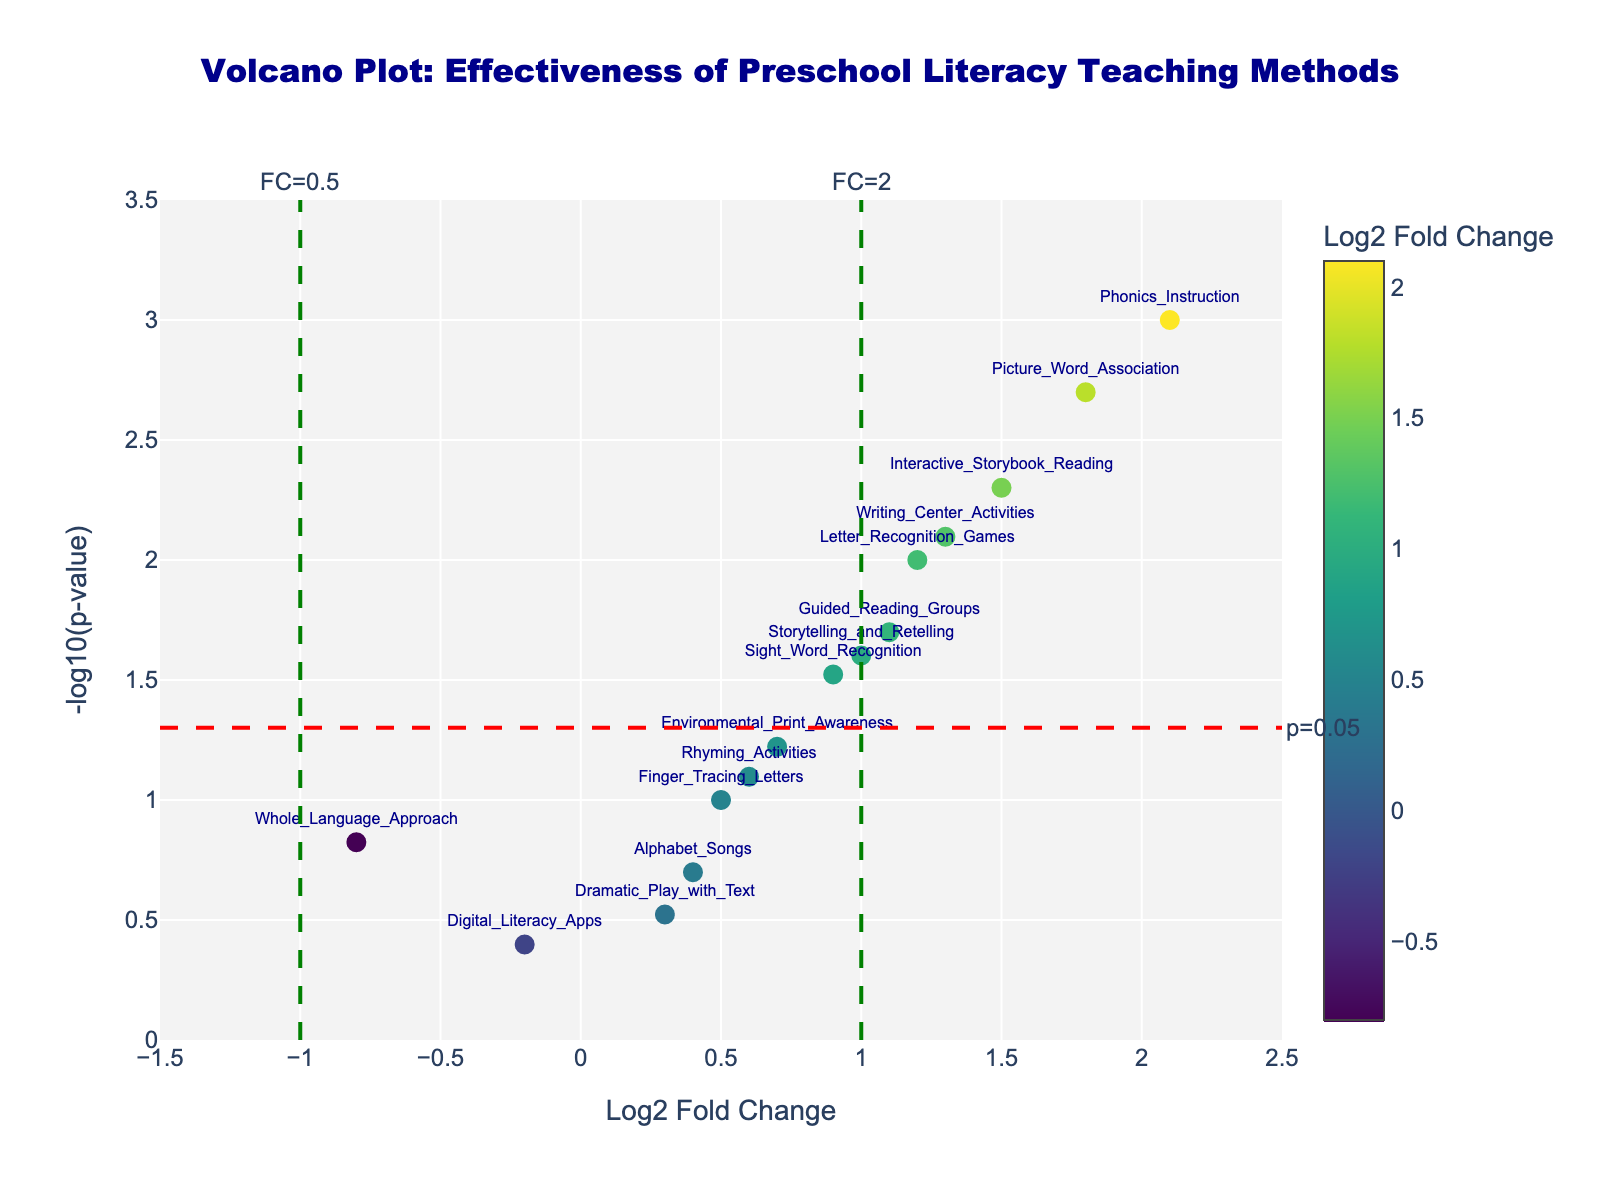How many teaching methods are shown in the volcano plot? Count the number of markers representing teaching methods in the figure. Each marker corresponds to one method.
Answer: 15 Which teaching method has the highest log2 fold change? Identify the marker positioned furthest to the right on the x-axis (log2 fold change) and check the label or hover text.
Answer: Phonics Instruction What is the p-value threshold represented by the horizontal red dashed line? The annotation on the horizontal red dashed line indicates the p-value threshold. The value is typically marked next to the line.
Answer: 0.05 Which teaching methods are considered statistically significant? Look for markers above the horizontal red dashed line (p=0.05) since these values have -log10(p) > -log10(0.05).
Answer: Phonics Instruction, Interactive Storybook Reading, Picture Word Association, Writing Center Activities, Guided Reading Groups, Sight Word Recognition, Storytelling and Retelling, Letter Recognition Games What is the log2 fold change threshold represented by the vertical green dashed lines? The annotations next to the vertical green dashed lines indicate the fold change thresholds.
Answer: 1 and -1 (FC=2 and FC=0.5) Which method has the biggest negative log2 fold change (showing lesser/no effectiveness)? Locate the marker furthest to the left (negative side) on the x-axis and check the label or hover text.
Answer: Whole Language Approach Out of the statistically significant methods, which has the smallest p-value? Among the methods above the horizontal red dashed line, identify the one with the highest y-value (-log10(p)).
Answer: Phonics Instruction How many teaching methods have a log2 fold change greater than 1? Count the markers located to the right of the vertical green dashed line at x=1.
Answer: 5 What is the fold change for "Interactive Storybook Reading"? Find the marker labeled "Interactive Storybook Reading" and check its x-axis value (log2 fold change).
Answer: 1.5 Is "Alphabet Songs" statistically significant? Check if the marker for "Alphabet Songs" is above the horizontal red dashed line (p=0.05).
Answer: No 